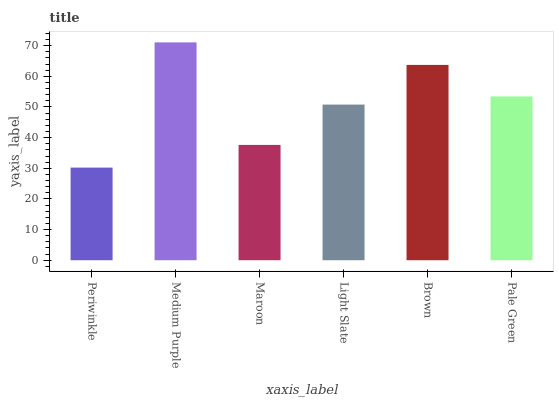Is Periwinkle the minimum?
Answer yes or no. Yes. Is Medium Purple the maximum?
Answer yes or no. Yes. Is Maroon the minimum?
Answer yes or no. No. Is Maroon the maximum?
Answer yes or no. No. Is Medium Purple greater than Maroon?
Answer yes or no. Yes. Is Maroon less than Medium Purple?
Answer yes or no. Yes. Is Maroon greater than Medium Purple?
Answer yes or no. No. Is Medium Purple less than Maroon?
Answer yes or no. No. Is Pale Green the high median?
Answer yes or no. Yes. Is Light Slate the low median?
Answer yes or no. Yes. Is Maroon the high median?
Answer yes or no. No. Is Brown the low median?
Answer yes or no. No. 